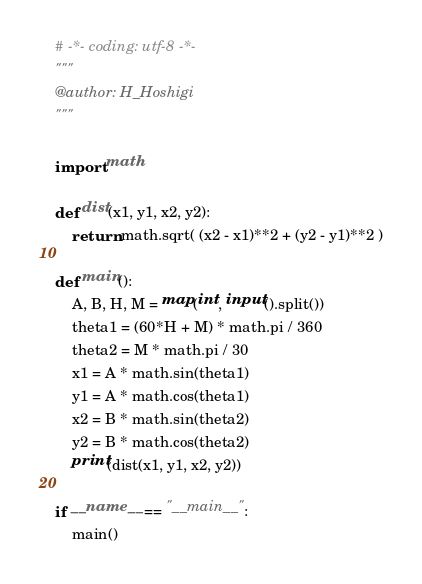Convert code to text. <code><loc_0><loc_0><loc_500><loc_500><_Python_># -*- coding: utf-8 -*-
"""
@author: H_Hoshigi
"""

import math

def dist(x1, y1, x2, y2):
    return math.sqrt( (x2 - x1)**2 + (y2 - y1)**2 )

def main():
    A, B, H, M = map(int, input().split())
    theta1 = (60*H + M) * math.pi / 360
    theta2 = M * math.pi / 30
    x1 = A * math.sin(theta1)
    y1 = A * math.cos(theta1)
    x2 = B * math.sin(theta2)
    y2 = B * math.cos(theta2)
    print(dist(x1, y1, x2, y2))

if __name__ == "__main__":
    main()


</code> 